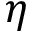Convert formula to latex. <formula><loc_0><loc_0><loc_500><loc_500>\eta</formula> 